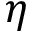Convert formula to latex. <formula><loc_0><loc_0><loc_500><loc_500>\eta</formula> 